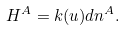<formula> <loc_0><loc_0><loc_500><loc_500>H ^ { A } = k ( u ) d n ^ { A } .</formula> 